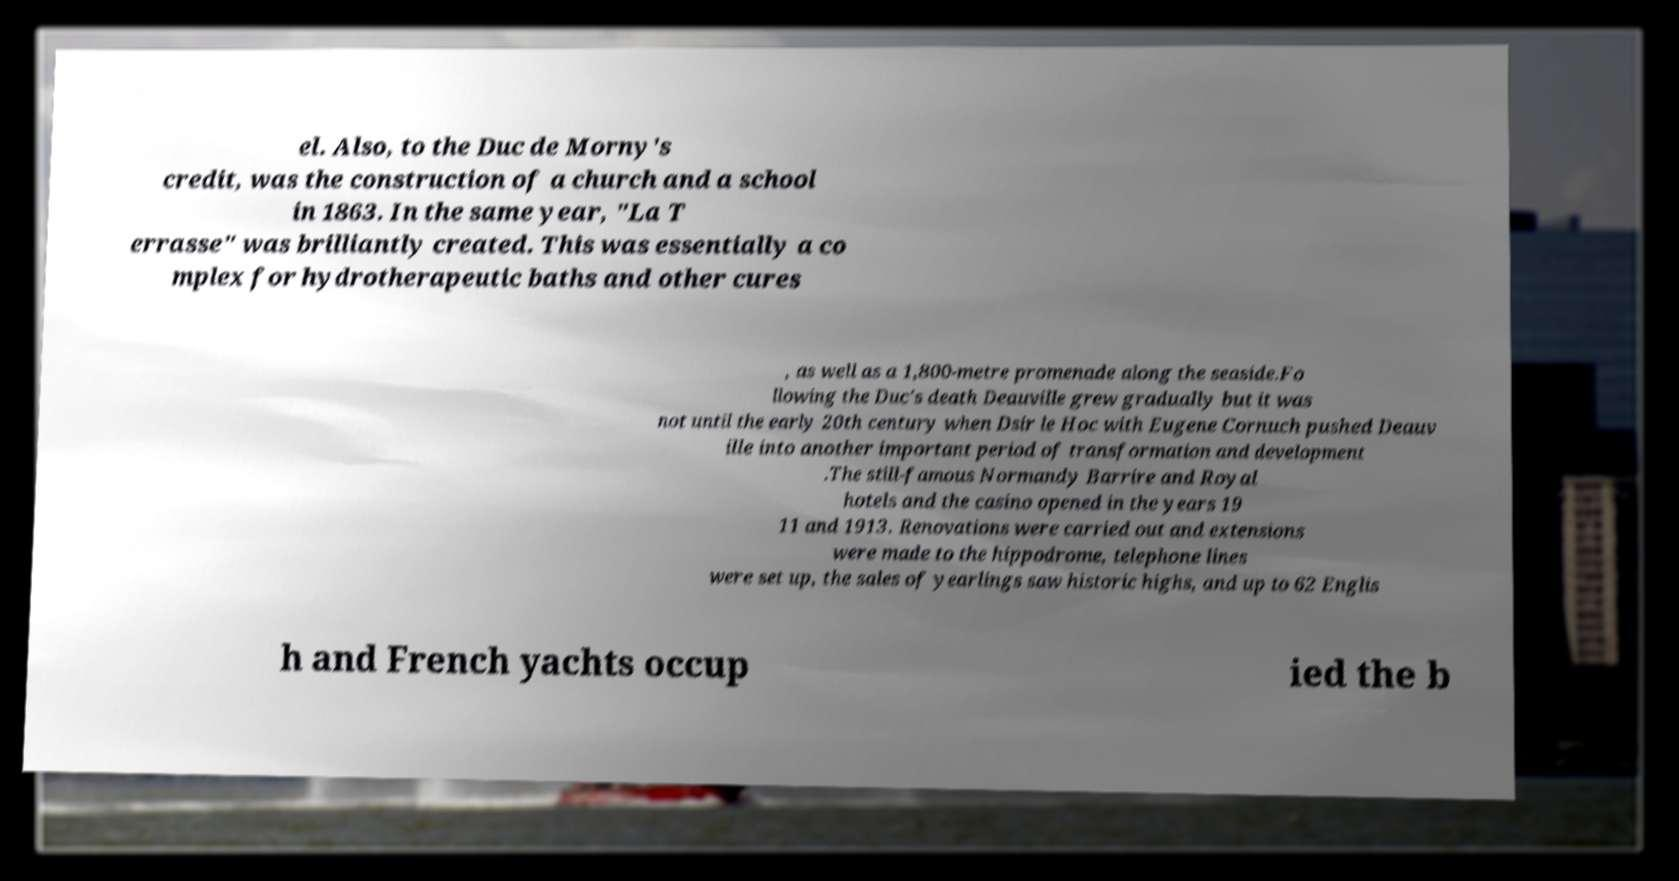For documentation purposes, I need the text within this image transcribed. Could you provide that? el. Also, to the Duc de Morny's credit, was the construction of a church and a school in 1863. In the same year, "La T errasse" was brilliantly created. This was essentially a co mplex for hydrotherapeutic baths and other cures , as well as a 1,800-metre promenade along the seaside.Fo llowing the Duc's death Deauville grew gradually but it was not until the early 20th century when Dsir le Hoc with Eugene Cornuch pushed Deauv ille into another important period of transformation and development .The still-famous Normandy Barrire and Royal hotels and the casino opened in the years 19 11 and 1913. Renovations were carried out and extensions were made to the hippodrome, telephone lines were set up, the sales of yearlings saw historic highs, and up to 62 Englis h and French yachts occup ied the b 